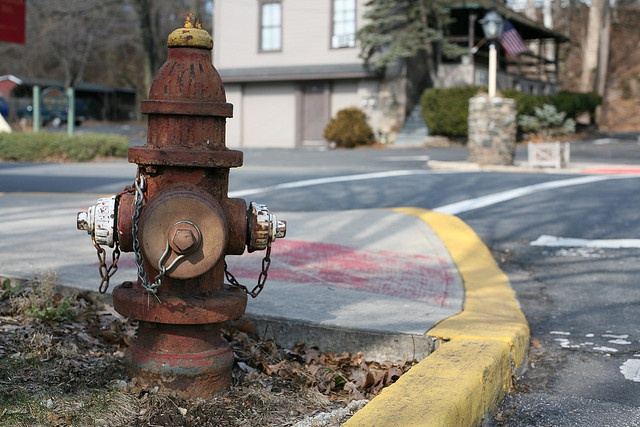Describe the objects in this image and their specific colors. I can see fire hydrant in maroon, black, and gray tones and car in maroon, gray, black, purple, and darkgray tones in this image. 